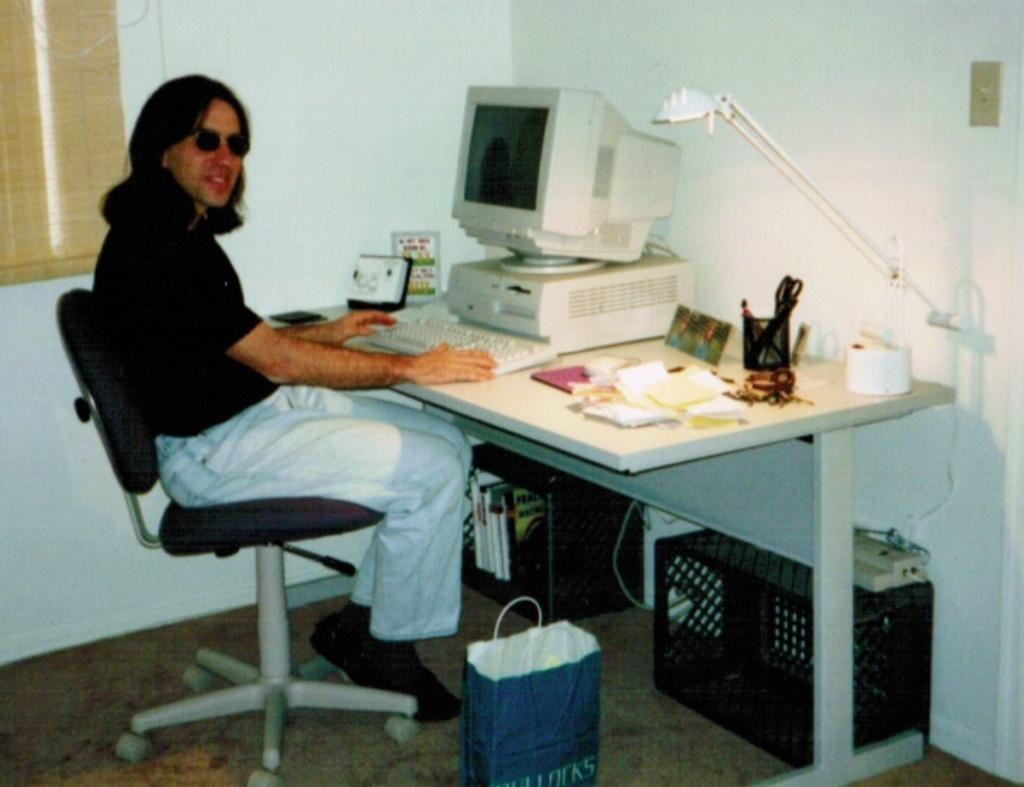What is the color of the wall in the image? The wall in the image is white. What is the man in the image doing? The man is sitting on a chair in the image. What is covering the man in the image? There is a cover in the image. What is on the table in the image? There is a table in the image with papers, tissues, a light, a keyboard, and a screen on it. What type of hair is the man wearing in the image? There is no mention of hair in the image; the man is covered by a cover. Is there a letter addressed to the man on the table in the image? There is no mention of a letter on the table in the image. 